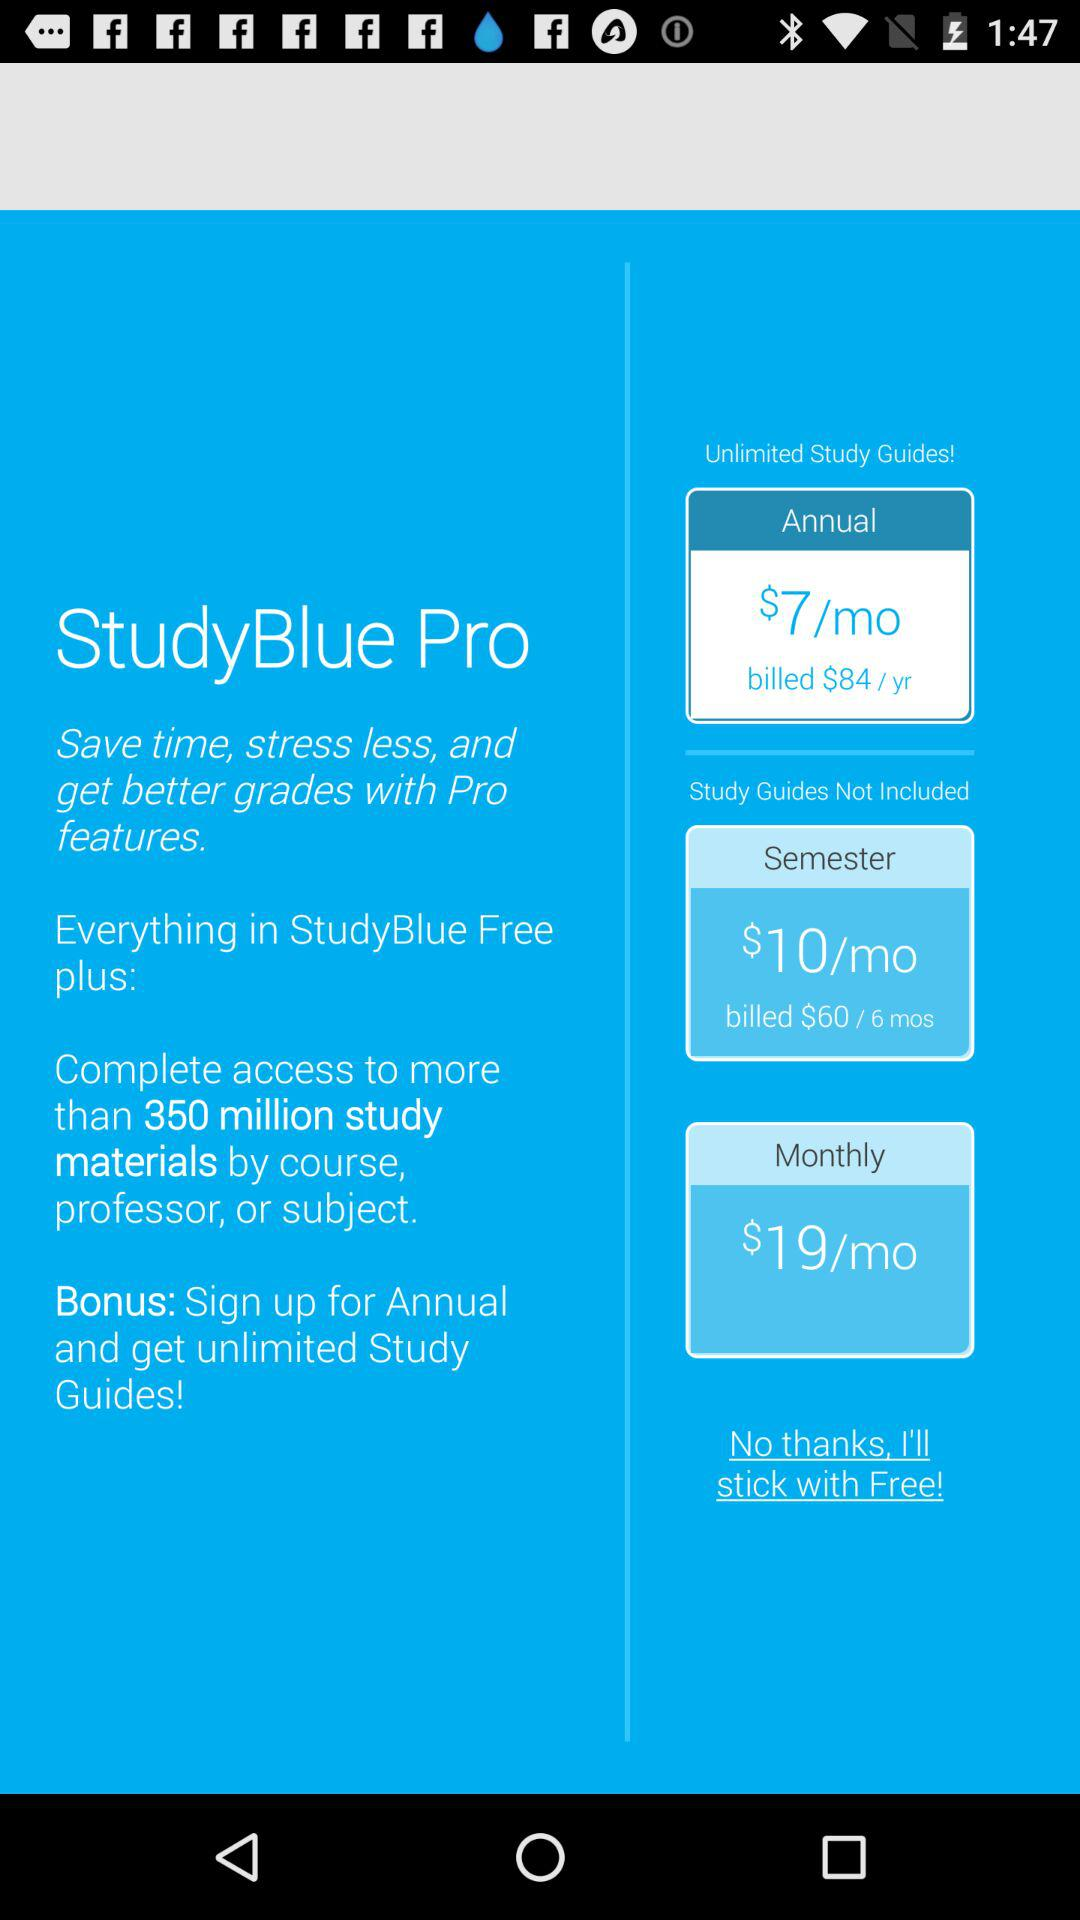What is the monthly cost? The cost is $19/month. 